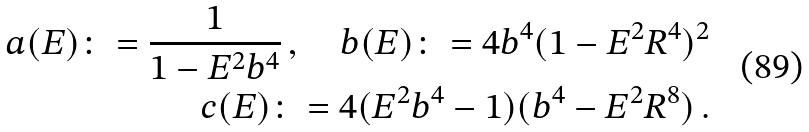Convert formula to latex. <formula><loc_0><loc_0><loc_500><loc_500>a ( E ) \colon = \frac { 1 } { 1 - E ^ { 2 } b ^ { 4 } } \, , \quad b ( E ) \colon = 4 b ^ { 4 } ( 1 - E ^ { 2 } R ^ { 4 } ) ^ { 2 } \\ c ( E ) \colon = 4 ( E ^ { 2 } b ^ { 4 } - 1 ) ( b ^ { 4 } - E ^ { 2 } R ^ { 8 } ) \, .</formula> 